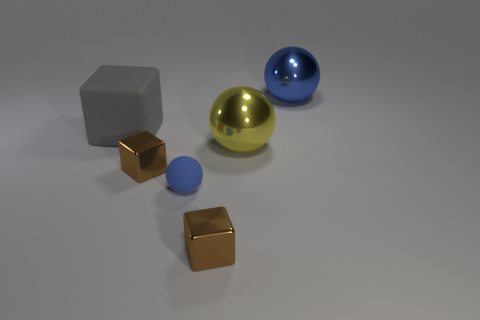Subtract all yellow cubes. How many blue balls are left? 2 Subtract 1 blocks. How many blocks are left? 2 Subtract all tiny metallic cubes. How many cubes are left? 1 Subtract all purple balls. Subtract all brown cylinders. How many balls are left? 3 Add 1 big gray things. How many objects exist? 7 Subtract all tiny cylinders. Subtract all large objects. How many objects are left? 3 Add 5 spheres. How many spheres are left? 8 Add 2 big blue metallic objects. How many big blue metallic objects exist? 3 Subtract 1 yellow balls. How many objects are left? 5 